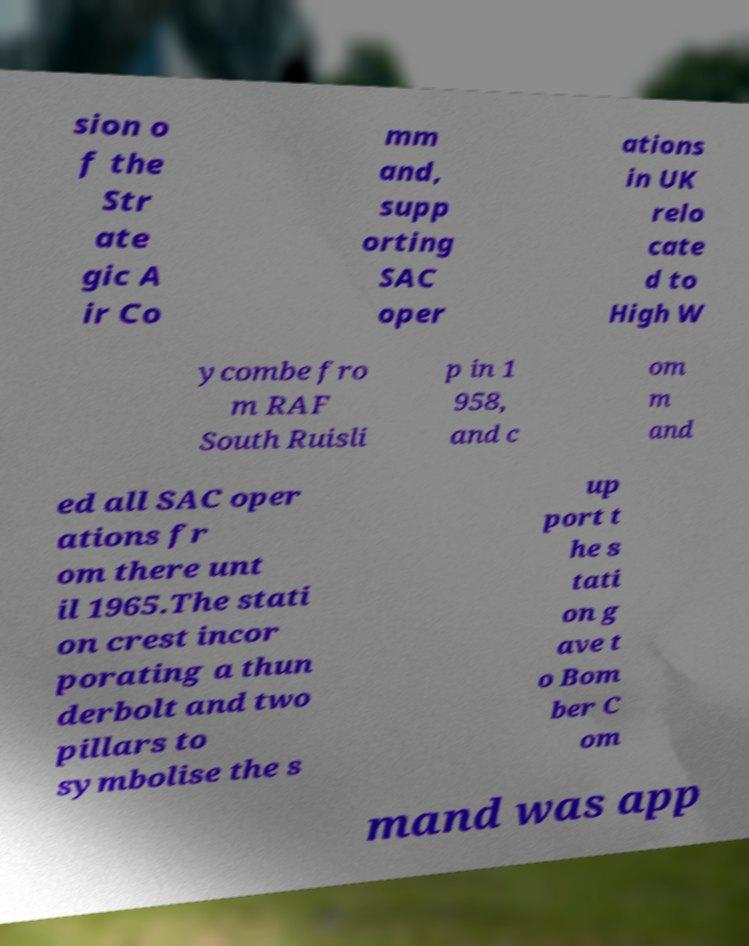Please identify and transcribe the text found in this image. sion o f the Str ate gic A ir Co mm and, supp orting SAC oper ations in UK relo cate d to High W ycombe fro m RAF South Ruisli p in 1 958, and c om m and ed all SAC oper ations fr om there unt il 1965.The stati on crest incor porating a thun derbolt and two pillars to symbolise the s up port t he s tati on g ave t o Bom ber C om mand was app 